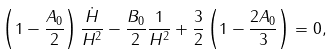Convert formula to latex. <formula><loc_0><loc_0><loc_500><loc_500>\left ( 1 - \frac { A _ { 0 } } { 2 } \right ) \frac { \dot { H } } { H ^ { 2 } } - \frac { B _ { 0 } } { 2 } \frac { 1 } { H ^ { 2 } } + \frac { 3 } { 2 } \left ( 1 - \frac { 2 A _ { 0 } } { 3 } \right ) = 0 ,</formula> 